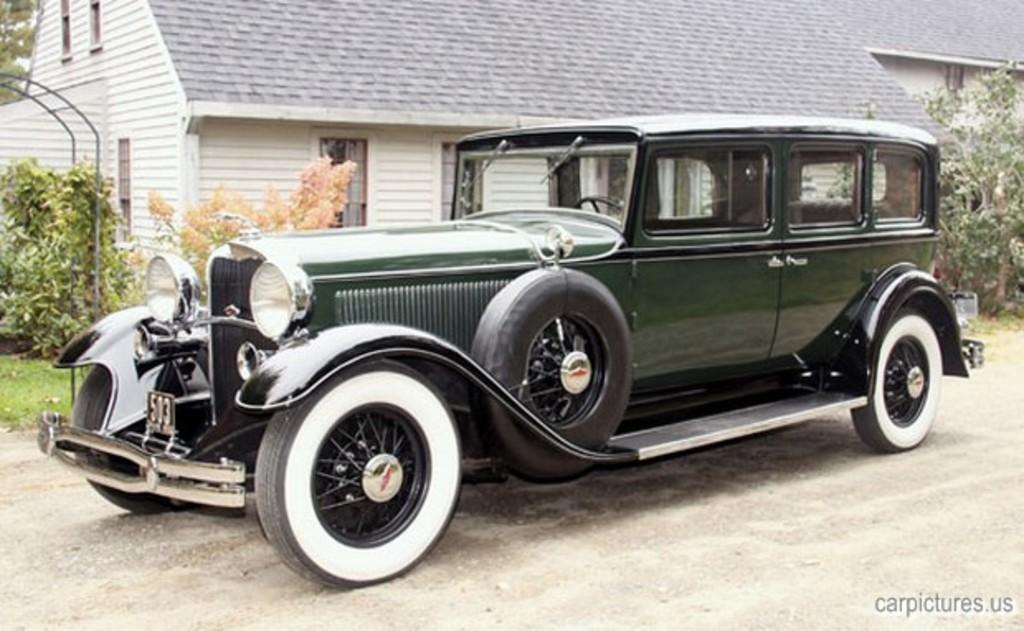Can you describe this image briefly? In this image I can see a car which is green, black and white in color on the ground. In the background I can see few trees, a house which is white and grey in color, few flowers which are pink in color and few metal rods. 